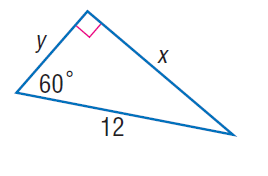Question: Find x.
Choices:
A. 2 \sqrt { 3 }
B. 3 \sqrt { 3 }
C. 5 \sqrt { 3 }
D. 6 \sqrt { 3 }
Answer with the letter. Answer: D 